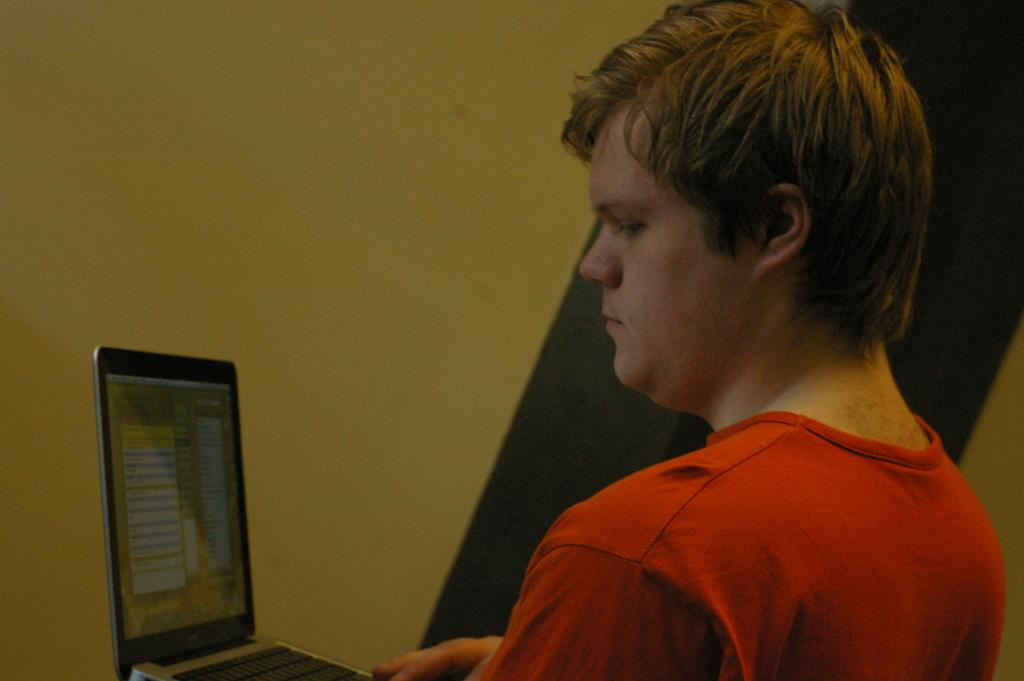Who is present in the image? There is a person in the image. What is the person wearing? The person is wearing a t-shirt. What object is the person holding? The person is holding a laptop. What can be seen in the background of the image? There is a wall in the background of the image. What type of fruit is the person eating in the image? There is no fruit present in the image; the person is holding a laptop. 